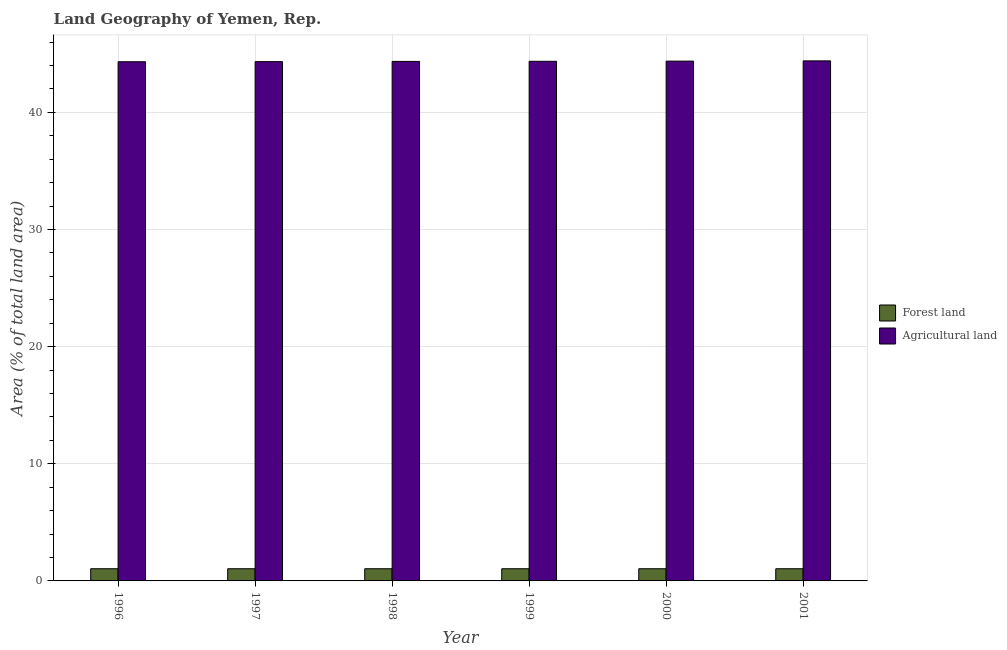Are the number of bars on each tick of the X-axis equal?
Provide a succinct answer. Yes. How many bars are there on the 3rd tick from the left?
Make the answer very short. 2. What is the label of the 6th group of bars from the left?
Give a very brief answer. 2001. What is the percentage of land area under agriculture in 1997?
Your response must be concise. 44.33. Across all years, what is the maximum percentage of land area under agriculture?
Make the answer very short. 44.39. Across all years, what is the minimum percentage of land area under agriculture?
Your answer should be very brief. 44.32. What is the total percentage of land area under forests in the graph?
Make the answer very short. 6.24. What is the difference between the percentage of land area under agriculture in 1999 and that in 2000?
Ensure brevity in your answer.  -0.02. What is the average percentage of land area under forests per year?
Provide a short and direct response. 1.04. In how many years, is the percentage of land area under forests greater than 12 %?
Your answer should be compact. 0. What is the difference between the highest and the second highest percentage of land area under agriculture?
Give a very brief answer. 0.02. In how many years, is the percentage of land area under agriculture greater than the average percentage of land area under agriculture taken over all years?
Offer a terse response. 3. Is the sum of the percentage of land area under agriculture in 1998 and 1999 greater than the maximum percentage of land area under forests across all years?
Ensure brevity in your answer.  Yes. What does the 2nd bar from the left in 2001 represents?
Offer a terse response. Agricultural land. What does the 2nd bar from the right in 1998 represents?
Offer a very short reply. Forest land. Are all the bars in the graph horizontal?
Your response must be concise. No. How many years are there in the graph?
Your response must be concise. 6. Are the values on the major ticks of Y-axis written in scientific E-notation?
Provide a short and direct response. No. Does the graph contain any zero values?
Make the answer very short. No. Does the graph contain grids?
Offer a very short reply. Yes. Where does the legend appear in the graph?
Keep it short and to the point. Center right. How are the legend labels stacked?
Your response must be concise. Vertical. What is the title of the graph?
Provide a short and direct response. Land Geography of Yemen, Rep. What is the label or title of the Y-axis?
Ensure brevity in your answer.  Area (% of total land area). What is the Area (% of total land area) of Forest land in 1996?
Offer a very short reply. 1.04. What is the Area (% of total land area) in Agricultural land in 1996?
Ensure brevity in your answer.  44.32. What is the Area (% of total land area) of Forest land in 1997?
Give a very brief answer. 1.04. What is the Area (% of total land area) of Agricultural land in 1997?
Your answer should be very brief. 44.33. What is the Area (% of total land area) in Forest land in 1998?
Ensure brevity in your answer.  1.04. What is the Area (% of total land area) in Agricultural land in 1998?
Provide a short and direct response. 44.35. What is the Area (% of total land area) in Forest land in 1999?
Offer a terse response. 1.04. What is the Area (% of total land area) in Agricultural land in 1999?
Give a very brief answer. 44.35. What is the Area (% of total land area) in Forest land in 2000?
Keep it short and to the point. 1.04. What is the Area (% of total land area) of Agricultural land in 2000?
Offer a very short reply. 44.37. What is the Area (% of total land area) of Forest land in 2001?
Your response must be concise. 1.04. What is the Area (% of total land area) of Agricultural land in 2001?
Offer a very short reply. 44.39. Across all years, what is the maximum Area (% of total land area) of Forest land?
Give a very brief answer. 1.04. Across all years, what is the maximum Area (% of total land area) in Agricultural land?
Provide a short and direct response. 44.39. Across all years, what is the minimum Area (% of total land area) in Forest land?
Provide a succinct answer. 1.04. Across all years, what is the minimum Area (% of total land area) in Agricultural land?
Make the answer very short. 44.32. What is the total Area (% of total land area) of Forest land in the graph?
Give a very brief answer. 6.24. What is the total Area (% of total land area) in Agricultural land in the graph?
Offer a terse response. 266.1. What is the difference between the Area (% of total land area) in Forest land in 1996 and that in 1997?
Your response must be concise. 0. What is the difference between the Area (% of total land area) of Agricultural land in 1996 and that in 1997?
Provide a succinct answer. -0.01. What is the difference between the Area (% of total land area) in Forest land in 1996 and that in 1998?
Provide a succinct answer. 0. What is the difference between the Area (% of total land area) in Agricultural land in 1996 and that in 1998?
Your answer should be compact. -0.03. What is the difference between the Area (% of total land area) in Agricultural land in 1996 and that in 1999?
Your answer should be very brief. -0.04. What is the difference between the Area (% of total land area) of Agricultural land in 1996 and that in 2000?
Keep it short and to the point. -0.05. What is the difference between the Area (% of total land area) in Forest land in 1996 and that in 2001?
Ensure brevity in your answer.  0. What is the difference between the Area (% of total land area) in Agricultural land in 1996 and that in 2001?
Keep it short and to the point. -0.07. What is the difference between the Area (% of total land area) of Forest land in 1997 and that in 1998?
Offer a very short reply. 0. What is the difference between the Area (% of total land area) of Agricultural land in 1997 and that in 1998?
Give a very brief answer. -0.02. What is the difference between the Area (% of total land area) of Agricultural land in 1997 and that in 1999?
Offer a very short reply. -0.03. What is the difference between the Area (% of total land area) of Forest land in 1997 and that in 2000?
Provide a short and direct response. 0. What is the difference between the Area (% of total land area) in Agricultural land in 1997 and that in 2000?
Provide a short and direct response. -0.04. What is the difference between the Area (% of total land area) of Agricultural land in 1997 and that in 2001?
Ensure brevity in your answer.  -0.06. What is the difference between the Area (% of total land area) of Agricultural land in 1998 and that in 1999?
Keep it short and to the point. -0.01. What is the difference between the Area (% of total land area) in Agricultural land in 1998 and that in 2000?
Provide a short and direct response. -0.02. What is the difference between the Area (% of total land area) in Agricultural land in 1998 and that in 2001?
Offer a very short reply. -0.05. What is the difference between the Area (% of total land area) in Agricultural land in 1999 and that in 2000?
Offer a very short reply. -0.02. What is the difference between the Area (% of total land area) in Forest land in 1999 and that in 2001?
Provide a short and direct response. 0. What is the difference between the Area (% of total land area) of Agricultural land in 1999 and that in 2001?
Your answer should be compact. -0.04. What is the difference between the Area (% of total land area) in Forest land in 2000 and that in 2001?
Your response must be concise. 0. What is the difference between the Area (% of total land area) in Agricultural land in 2000 and that in 2001?
Offer a very short reply. -0.02. What is the difference between the Area (% of total land area) of Forest land in 1996 and the Area (% of total land area) of Agricultural land in 1997?
Your answer should be very brief. -43.29. What is the difference between the Area (% of total land area) of Forest land in 1996 and the Area (% of total land area) of Agricultural land in 1998?
Provide a succinct answer. -43.31. What is the difference between the Area (% of total land area) in Forest land in 1996 and the Area (% of total land area) in Agricultural land in 1999?
Your answer should be compact. -43.31. What is the difference between the Area (% of total land area) of Forest land in 1996 and the Area (% of total land area) of Agricultural land in 2000?
Offer a very short reply. -43.33. What is the difference between the Area (% of total land area) in Forest land in 1996 and the Area (% of total land area) in Agricultural land in 2001?
Your response must be concise. -43.35. What is the difference between the Area (% of total land area) in Forest land in 1997 and the Area (% of total land area) in Agricultural land in 1998?
Offer a very short reply. -43.31. What is the difference between the Area (% of total land area) of Forest land in 1997 and the Area (% of total land area) of Agricultural land in 1999?
Ensure brevity in your answer.  -43.31. What is the difference between the Area (% of total land area) of Forest land in 1997 and the Area (% of total land area) of Agricultural land in 2000?
Keep it short and to the point. -43.33. What is the difference between the Area (% of total land area) in Forest land in 1997 and the Area (% of total land area) in Agricultural land in 2001?
Your answer should be compact. -43.35. What is the difference between the Area (% of total land area) of Forest land in 1998 and the Area (% of total land area) of Agricultural land in 1999?
Ensure brevity in your answer.  -43.31. What is the difference between the Area (% of total land area) in Forest land in 1998 and the Area (% of total land area) in Agricultural land in 2000?
Your answer should be very brief. -43.33. What is the difference between the Area (% of total land area) in Forest land in 1998 and the Area (% of total land area) in Agricultural land in 2001?
Provide a short and direct response. -43.35. What is the difference between the Area (% of total land area) in Forest land in 1999 and the Area (% of total land area) in Agricultural land in 2000?
Offer a very short reply. -43.33. What is the difference between the Area (% of total land area) of Forest land in 1999 and the Area (% of total land area) of Agricultural land in 2001?
Your answer should be very brief. -43.35. What is the difference between the Area (% of total land area) in Forest land in 2000 and the Area (% of total land area) in Agricultural land in 2001?
Your answer should be very brief. -43.35. What is the average Area (% of total land area) in Forest land per year?
Offer a very short reply. 1.04. What is the average Area (% of total land area) in Agricultural land per year?
Ensure brevity in your answer.  44.35. In the year 1996, what is the difference between the Area (% of total land area) of Forest land and Area (% of total land area) of Agricultural land?
Make the answer very short. -43.28. In the year 1997, what is the difference between the Area (% of total land area) in Forest land and Area (% of total land area) in Agricultural land?
Your answer should be very brief. -43.29. In the year 1998, what is the difference between the Area (% of total land area) in Forest land and Area (% of total land area) in Agricultural land?
Ensure brevity in your answer.  -43.31. In the year 1999, what is the difference between the Area (% of total land area) of Forest land and Area (% of total land area) of Agricultural land?
Your answer should be very brief. -43.31. In the year 2000, what is the difference between the Area (% of total land area) in Forest land and Area (% of total land area) in Agricultural land?
Provide a short and direct response. -43.33. In the year 2001, what is the difference between the Area (% of total land area) in Forest land and Area (% of total land area) in Agricultural land?
Your response must be concise. -43.35. What is the ratio of the Area (% of total land area) in Agricultural land in 1996 to that in 1997?
Provide a succinct answer. 1. What is the ratio of the Area (% of total land area) in Forest land in 1996 to that in 1999?
Offer a terse response. 1. What is the ratio of the Area (% of total land area) in Forest land in 1996 to that in 2000?
Your response must be concise. 1. What is the ratio of the Area (% of total land area) in Agricultural land in 1996 to that in 2000?
Your response must be concise. 1. What is the ratio of the Area (% of total land area) of Forest land in 1996 to that in 2001?
Your response must be concise. 1. What is the ratio of the Area (% of total land area) of Forest land in 1997 to that in 1998?
Keep it short and to the point. 1. What is the ratio of the Area (% of total land area) in Forest land in 1997 to that in 1999?
Make the answer very short. 1. What is the ratio of the Area (% of total land area) in Agricultural land in 1997 to that in 1999?
Offer a very short reply. 1. What is the ratio of the Area (% of total land area) of Forest land in 1997 to that in 2000?
Your answer should be compact. 1. What is the ratio of the Area (% of total land area) in Agricultural land in 1997 to that in 2000?
Ensure brevity in your answer.  1. What is the ratio of the Area (% of total land area) in Agricultural land in 1997 to that in 2001?
Ensure brevity in your answer.  1. What is the ratio of the Area (% of total land area) of Agricultural land in 1998 to that in 1999?
Provide a succinct answer. 1. What is the ratio of the Area (% of total land area) in Agricultural land in 1998 to that in 2000?
Offer a terse response. 1. What is the ratio of the Area (% of total land area) of Agricultural land in 1999 to that in 2001?
Offer a terse response. 1. What is the ratio of the Area (% of total land area) in Forest land in 2000 to that in 2001?
Offer a terse response. 1. What is the ratio of the Area (% of total land area) of Agricultural land in 2000 to that in 2001?
Offer a terse response. 1. What is the difference between the highest and the second highest Area (% of total land area) in Forest land?
Your response must be concise. 0. What is the difference between the highest and the second highest Area (% of total land area) of Agricultural land?
Provide a succinct answer. 0.02. What is the difference between the highest and the lowest Area (% of total land area) in Agricultural land?
Provide a succinct answer. 0.07. 